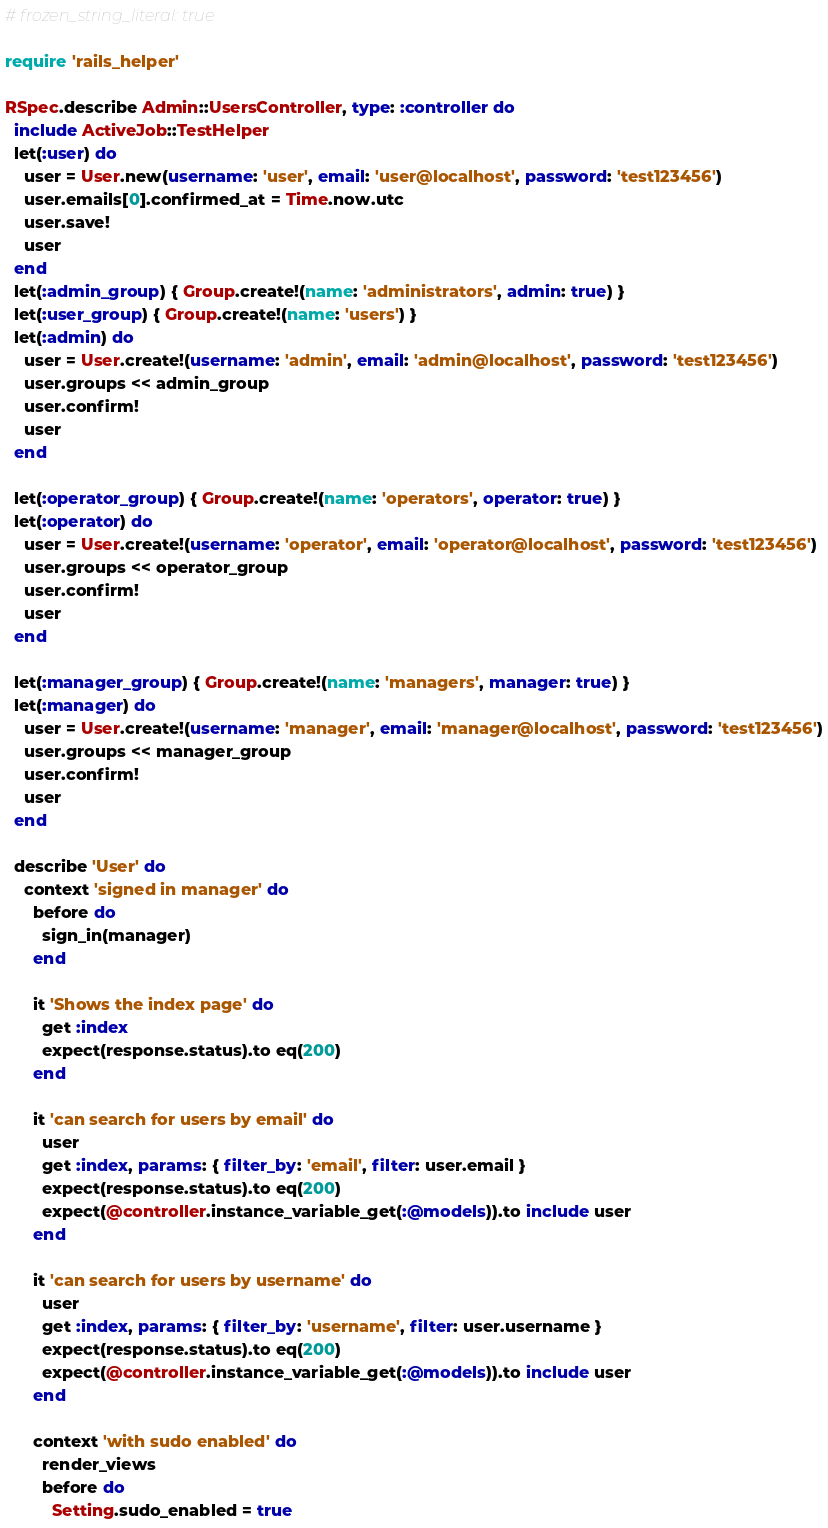Convert code to text. <code><loc_0><loc_0><loc_500><loc_500><_Ruby_># frozen_string_literal: true

require 'rails_helper'

RSpec.describe Admin::UsersController, type: :controller do
  include ActiveJob::TestHelper
  let(:user) do
    user = User.new(username: 'user', email: 'user@localhost', password: 'test123456')
    user.emails[0].confirmed_at = Time.now.utc
    user.save!
    user
  end
  let(:admin_group) { Group.create!(name: 'administrators', admin: true) }
  let(:user_group) { Group.create!(name: 'users') }
  let(:admin) do
    user = User.create!(username: 'admin', email: 'admin@localhost', password: 'test123456')
    user.groups << admin_group
    user.confirm!
    user
  end

  let(:operator_group) { Group.create!(name: 'operators', operator: true) }
  let(:operator) do
    user = User.create!(username: 'operator', email: 'operator@localhost', password: 'test123456')
    user.groups << operator_group
    user.confirm!
    user
  end

  let(:manager_group) { Group.create!(name: 'managers', manager: true) }
  let(:manager) do
    user = User.create!(username: 'manager', email: 'manager@localhost', password: 'test123456')
    user.groups << manager_group
    user.confirm!
    user
  end

  describe 'User' do
    context 'signed in manager' do
      before do
        sign_in(manager)
      end

      it 'Shows the index page' do
        get :index
        expect(response.status).to eq(200)
      end

      it 'can search for users by email' do
        user
        get :index, params: { filter_by: 'email', filter: user.email }
        expect(response.status).to eq(200)
        expect(@controller.instance_variable_get(:@models)).to include user
      end

      it 'can search for users by username' do
        user
        get :index, params: { filter_by: 'username', filter: user.username }
        expect(response.status).to eq(200)
        expect(@controller.instance_variable_get(:@models)).to include user
      end

      context 'with sudo enabled' do
        render_views
        before do
          Setting.sudo_enabled = true</code> 